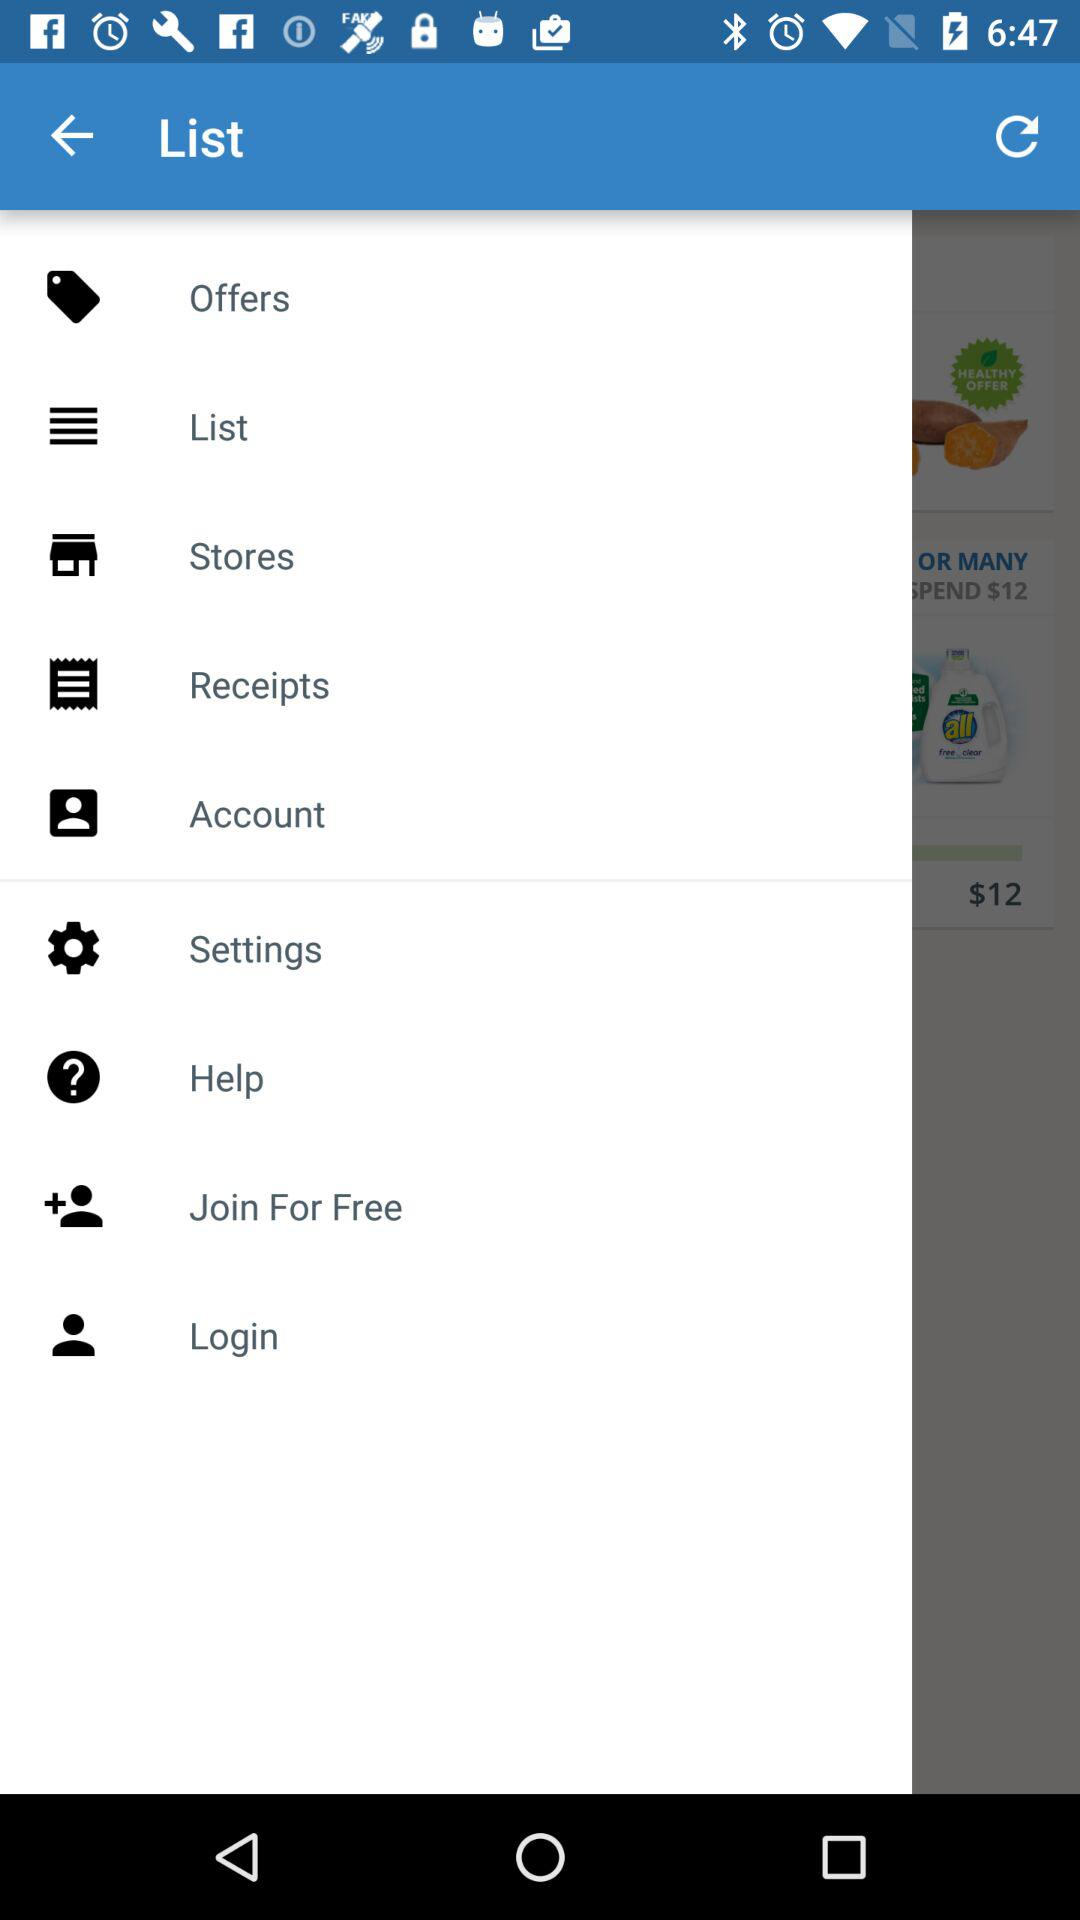How much money is saved by using the offers?
Answer the question using a single word or phrase. $12 